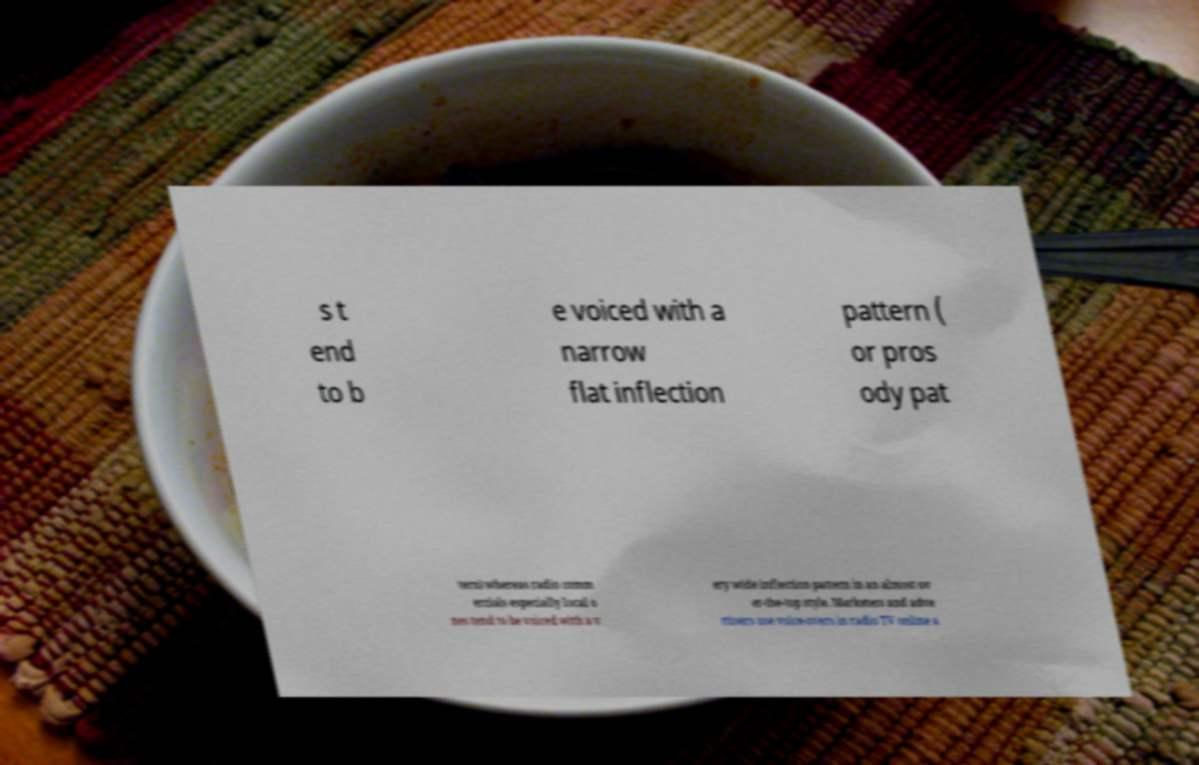For documentation purposes, I need the text within this image transcribed. Could you provide that? s t end to b e voiced with a narrow flat inflection pattern ( or pros ody pat tern) whereas radio comm ercials especially local o nes tend to be voiced with a v ery wide inflection pattern in an almost ov er-the-top style. Marketers and adve rtisers use voice-overs in radio TV online a 